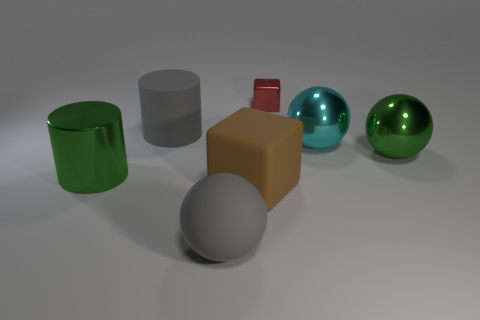Add 1 gray cylinders. How many objects exist? 8 Subtract all balls. How many objects are left? 4 Add 3 gray matte balls. How many gray matte balls are left? 4 Add 5 red shiny things. How many red shiny things exist? 6 Subtract 1 cyan spheres. How many objects are left? 6 Subtract all large purple cubes. Subtract all big cyan things. How many objects are left? 6 